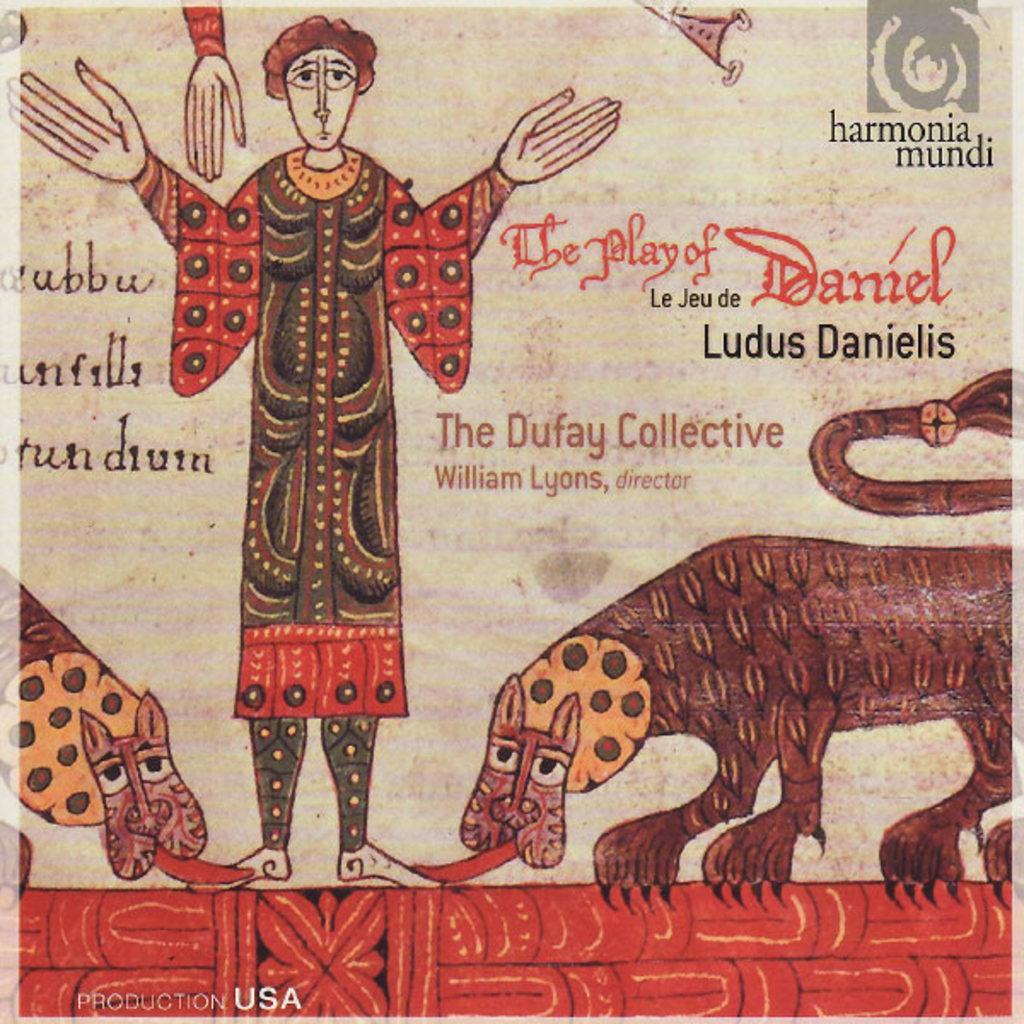Describe this image in one or two sentences. In this picture we can see a poster, here we can see depictions of a person and two animals, we can see some text here, at the right top we can see a logo. 